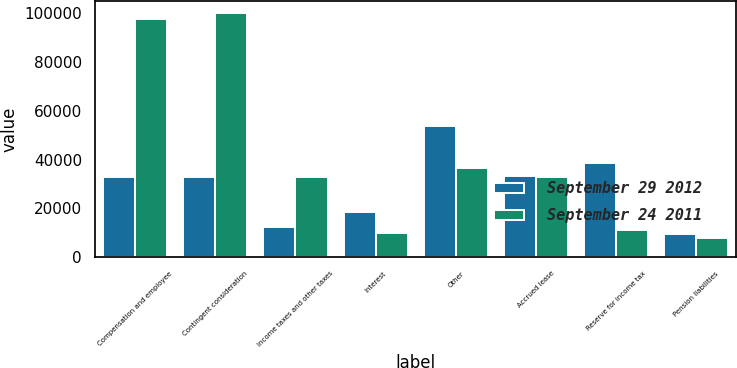Convert chart to OTSL. <chart><loc_0><loc_0><loc_500><loc_500><stacked_bar_chart><ecel><fcel>Compensation and employee<fcel>Contingent consideration<fcel>Income taxes and other taxes<fcel>Interest<fcel>Other<fcel>Accrued lease<fcel>Reserve for income tax<fcel>Pension liabilities<nl><fcel>September 29 2012<fcel>32958<fcel>32958<fcel>12424<fcel>18422<fcel>53981<fcel>33256<fcel>38518<fcel>9397<nl><fcel>September 24 2011<fcel>97747<fcel>100255<fcel>33070<fcel>9802<fcel>36504<fcel>32846<fcel>11202<fcel>7714<nl></chart> 